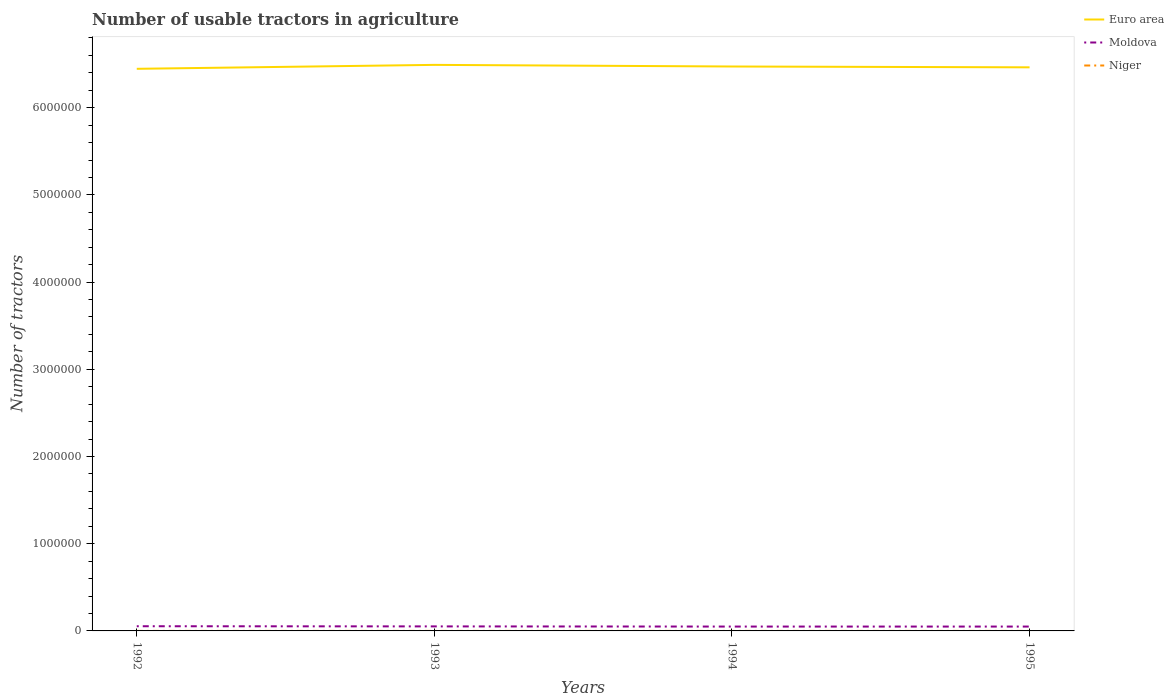How many different coloured lines are there?
Offer a terse response. 3. Is the number of lines equal to the number of legend labels?
Offer a very short reply. Yes. Across all years, what is the maximum number of usable tractors in agriculture in Moldova?
Provide a succinct answer. 5.00e+04. What is the total number of usable tractors in agriculture in Niger in the graph?
Offer a terse response. 10. What is the difference between the highest and the second highest number of usable tractors in agriculture in Moldova?
Offer a very short reply. 3867. How many lines are there?
Provide a succinct answer. 3. How many years are there in the graph?
Offer a terse response. 4. Are the values on the major ticks of Y-axis written in scientific E-notation?
Keep it short and to the point. No. Does the graph contain any zero values?
Your answer should be compact. No. Where does the legend appear in the graph?
Keep it short and to the point. Top right. How are the legend labels stacked?
Offer a terse response. Vertical. What is the title of the graph?
Offer a terse response. Number of usable tractors in agriculture. What is the label or title of the Y-axis?
Make the answer very short. Number of tractors. What is the Number of tractors in Euro area in 1992?
Your answer should be compact. 6.45e+06. What is the Number of tractors in Moldova in 1992?
Provide a short and direct response. 5.38e+04. What is the Number of tractors in Niger in 1992?
Give a very brief answer. 160. What is the Number of tractors of Euro area in 1993?
Offer a very short reply. 6.49e+06. What is the Number of tractors in Moldova in 1993?
Your response must be concise. 5.19e+04. What is the Number of tractors of Niger in 1993?
Give a very brief answer. 155. What is the Number of tractors of Euro area in 1994?
Ensure brevity in your answer.  6.47e+06. What is the Number of tractors of Niger in 1994?
Offer a very short reply. 150. What is the Number of tractors in Euro area in 1995?
Provide a short and direct response. 6.46e+06. What is the Number of tractors in Moldova in 1995?
Provide a short and direct response. 5.00e+04. What is the Number of tractors in Niger in 1995?
Your answer should be compact. 145. Across all years, what is the maximum Number of tractors in Euro area?
Ensure brevity in your answer.  6.49e+06. Across all years, what is the maximum Number of tractors of Moldova?
Offer a very short reply. 5.38e+04. Across all years, what is the maximum Number of tractors of Niger?
Offer a terse response. 160. Across all years, what is the minimum Number of tractors in Euro area?
Keep it short and to the point. 6.45e+06. Across all years, what is the minimum Number of tractors in Moldova?
Make the answer very short. 5.00e+04. Across all years, what is the minimum Number of tractors in Niger?
Give a very brief answer. 145. What is the total Number of tractors of Euro area in the graph?
Ensure brevity in your answer.  2.59e+07. What is the total Number of tractors of Moldova in the graph?
Provide a succinct answer. 2.06e+05. What is the total Number of tractors of Niger in the graph?
Make the answer very short. 610. What is the difference between the Number of tractors of Euro area in 1992 and that in 1993?
Ensure brevity in your answer.  -4.51e+04. What is the difference between the Number of tractors in Moldova in 1992 and that in 1993?
Make the answer very short. 1933. What is the difference between the Number of tractors of Niger in 1992 and that in 1993?
Ensure brevity in your answer.  5. What is the difference between the Number of tractors of Euro area in 1992 and that in 1994?
Give a very brief answer. -2.65e+04. What is the difference between the Number of tractors of Moldova in 1992 and that in 1994?
Make the answer very short. 3833. What is the difference between the Number of tractors in Niger in 1992 and that in 1994?
Give a very brief answer. 10. What is the difference between the Number of tractors of Euro area in 1992 and that in 1995?
Your answer should be very brief. -1.70e+04. What is the difference between the Number of tractors in Moldova in 1992 and that in 1995?
Make the answer very short. 3867. What is the difference between the Number of tractors in Niger in 1992 and that in 1995?
Provide a succinct answer. 15. What is the difference between the Number of tractors of Euro area in 1993 and that in 1994?
Give a very brief answer. 1.85e+04. What is the difference between the Number of tractors in Moldova in 1993 and that in 1994?
Make the answer very short. 1900. What is the difference between the Number of tractors in Euro area in 1993 and that in 1995?
Your answer should be very brief. 2.81e+04. What is the difference between the Number of tractors of Moldova in 1993 and that in 1995?
Give a very brief answer. 1934. What is the difference between the Number of tractors of Niger in 1993 and that in 1995?
Offer a very short reply. 10. What is the difference between the Number of tractors of Euro area in 1994 and that in 1995?
Offer a terse response. 9575. What is the difference between the Number of tractors of Euro area in 1992 and the Number of tractors of Moldova in 1993?
Provide a succinct answer. 6.39e+06. What is the difference between the Number of tractors of Euro area in 1992 and the Number of tractors of Niger in 1993?
Your answer should be compact. 6.45e+06. What is the difference between the Number of tractors in Moldova in 1992 and the Number of tractors in Niger in 1993?
Your answer should be compact. 5.37e+04. What is the difference between the Number of tractors of Euro area in 1992 and the Number of tractors of Moldova in 1994?
Your answer should be compact. 6.40e+06. What is the difference between the Number of tractors in Euro area in 1992 and the Number of tractors in Niger in 1994?
Offer a very short reply. 6.45e+06. What is the difference between the Number of tractors of Moldova in 1992 and the Number of tractors of Niger in 1994?
Keep it short and to the point. 5.37e+04. What is the difference between the Number of tractors of Euro area in 1992 and the Number of tractors of Moldova in 1995?
Give a very brief answer. 6.40e+06. What is the difference between the Number of tractors in Euro area in 1992 and the Number of tractors in Niger in 1995?
Make the answer very short. 6.45e+06. What is the difference between the Number of tractors of Moldova in 1992 and the Number of tractors of Niger in 1995?
Your answer should be compact. 5.37e+04. What is the difference between the Number of tractors of Euro area in 1993 and the Number of tractors of Moldova in 1994?
Offer a terse response. 6.44e+06. What is the difference between the Number of tractors of Euro area in 1993 and the Number of tractors of Niger in 1994?
Provide a succinct answer. 6.49e+06. What is the difference between the Number of tractors of Moldova in 1993 and the Number of tractors of Niger in 1994?
Offer a very short reply. 5.18e+04. What is the difference between the Number of tractors of Euro area in 1993 and the Number of tractors of Moldova in 1995?
Give a very brief answer. 6.44e+06. What is the difference between the Number of tractors in Euro area in 1993 and the Number of tractors in Niger in 1995?
Provide a succinct answer. 6.49e+06. What is the difference between the Number of tractors in Moldova in 1993 and the Number of tractors in Niger in 1995?
Provide a succinct answer. 5.18e+04. What is the difference between the Number of tractors in Euro area in 1994 and the Number of tractors in Moldova in 1995?
Provide a succinct answer. 6.42e+06. What is the difference between the Number of tractors of Euro area in 1994 and the Number of tractors of Niger in 1995?
Make the answer very short. 6.47e+06. What is the difference between the Number of tractors of Moldova in 1994 and the Number of tractors of Niger in 1995?
Give a very brief answer. 4.99e+04. What is the average Number of tractors of Euro area per year?
Keep it short and to the point. 6.47e+06. What is the average Number of tractors of Moldova per year?
Offer a very short reply. 5.14e+04. What is the average Number of tractors in Niger per year?
Your answer should be compact. 152.5. In the year 1992, what is the difference between the Number of tractors in Euro area and Number of tractors in Moldova?
Give a very brief answer. 6.39e+06. In the year 1992, what is the difference between the Number of tractors in Euro area and Number of tractors in Niger?
Your response must be concise. 6.45e+06. In the year 1992, what is the difference between the Number of tractors in Moldova and Number of tractors in Niger?
Offer a very short reply. 5.37e+04. In the year 1993, what is the difference between the Number of tractors of Euro area and Number of tractors of Moldova?
Give a very brief answer. 6.44e+06. In the year 1993, what is the difference between the Number of tractors in Euro area and Number of tractors in Niger?
Your answer should be compact. 6.49e+06. In the year 1993, what is the difference between the Number of tractors of Moldova and Number of tractors of Niger?
Provide a succinct answer. 5.17e+04. In the year 1994, what is the difference between the Number of tractors of Euro area and Number of tractors of Moldova?
Offer a very short reply. 6.42e+06. In the year 1994, what is the difference between the Number of tractors in Euro area and Number of tractors in Niger?
Your response must be concise. 6.47e+06. In the year 1994, what is the difference between the Number of tractors of Moldova and Number of tractors of Niger?
Offer a terse response. 4.98e+04. In the year 1995, what is the difference between the Number of tractors of Euro area and Number of tractors of Moldova?
Keep it short and to the point. 6.41e+06. In the year 1995, what is the difference between the Number of tractors of Euro area and Number of tractors of Niger?
Make the answer very short. 6.46e+06. In the year 1995, what is the difference between the Number of tractors in Moldova and Number of tractors in Niger?
Keep it short and to the point. 4.98e+04. What is the ratio of the Number of tractors in Moldova in 1992 to that in 1993?
Give a very brief answer. 1.04. What is the ratio of the Number of tractors in Niger in 1992 to that in 1993?
Keep it short and to the point. 1.03. What is the ratio of the Number of tractors in Moldova in 1992 to that in 1994?
Give a very brief answer. 1.08. What is the ratio of the Number of tractors of Niger in 1992 to that in 1994?
Offer a very short reply. 1.07. What is the ratio of the Number of tractors of Moldova in 1992 to that in 1995?
Give a very brief answer. 1.08. What is the ratio of the Number of tractors of Niger in 1992 to that in 1995?
Offer a very short reply. 1.1. What is the ratio of the Number of tractors in Euro area in 1993 to that in 1994?
Your answer should be very brief. 1. What is the ratio of the Number of tractors in Moldova in 1993 to that in 1994?
Offer a terse response. 1.04. What is the ratio of the Number of tractors in Moldova in 1993 to that in 1995?
Your answer should be compact. 1.04. What is the ratio of the Number of tractors of Niger in 1993 to that in 1995?
Provide a short and direct response. 1.07. What is the ratio of the Number of tractors in Niger in 1994 to that in 1995?
Ensure brevity in your answer.  1.03. What is the difference between the highest and the second highest Number of tractors in Euro area?
Ensure brevity in your answer.  1.85e+04. What is the difference between the highest and the second highest Number of tractors of Moldova?
Provide a short and direct response. 1933. What is the difference between the highest and the second highest Number of tractors in Niger?
Keep it short and to the point. 5. What is the difference between the highest and the lowest Number of tractors in Euro area?
Provide a succinct answer. 4.51e+04. What is the difference between the highest and the lowest Number of tractors of Moldova?
Your answer should be compact. 3867. What is the difference between the highest and the lowest Number of tractors of Niger?
Your response must be concise. 15. 